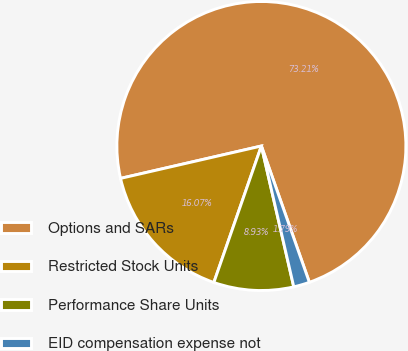Convert chart to OTSL. <chart><loc_0><loc_0><loc_500><loc_500><pie_chart><fcel>Options and SARs<fcel>Restricted Stock Units<fcel>Performance Share Units<fcel>EID compensation expense not<nl><fcel>73.21%<fcel>16.07%<fcel>8.93%<fcel>1.79%<nl></chart> 